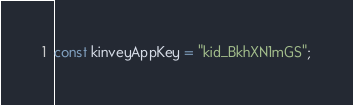<code> <loc_0><loc_0><loc_500><loc_500><_JavaScript_>const kinveyAppKey = "kid_BkhXN1mGS";</code> 